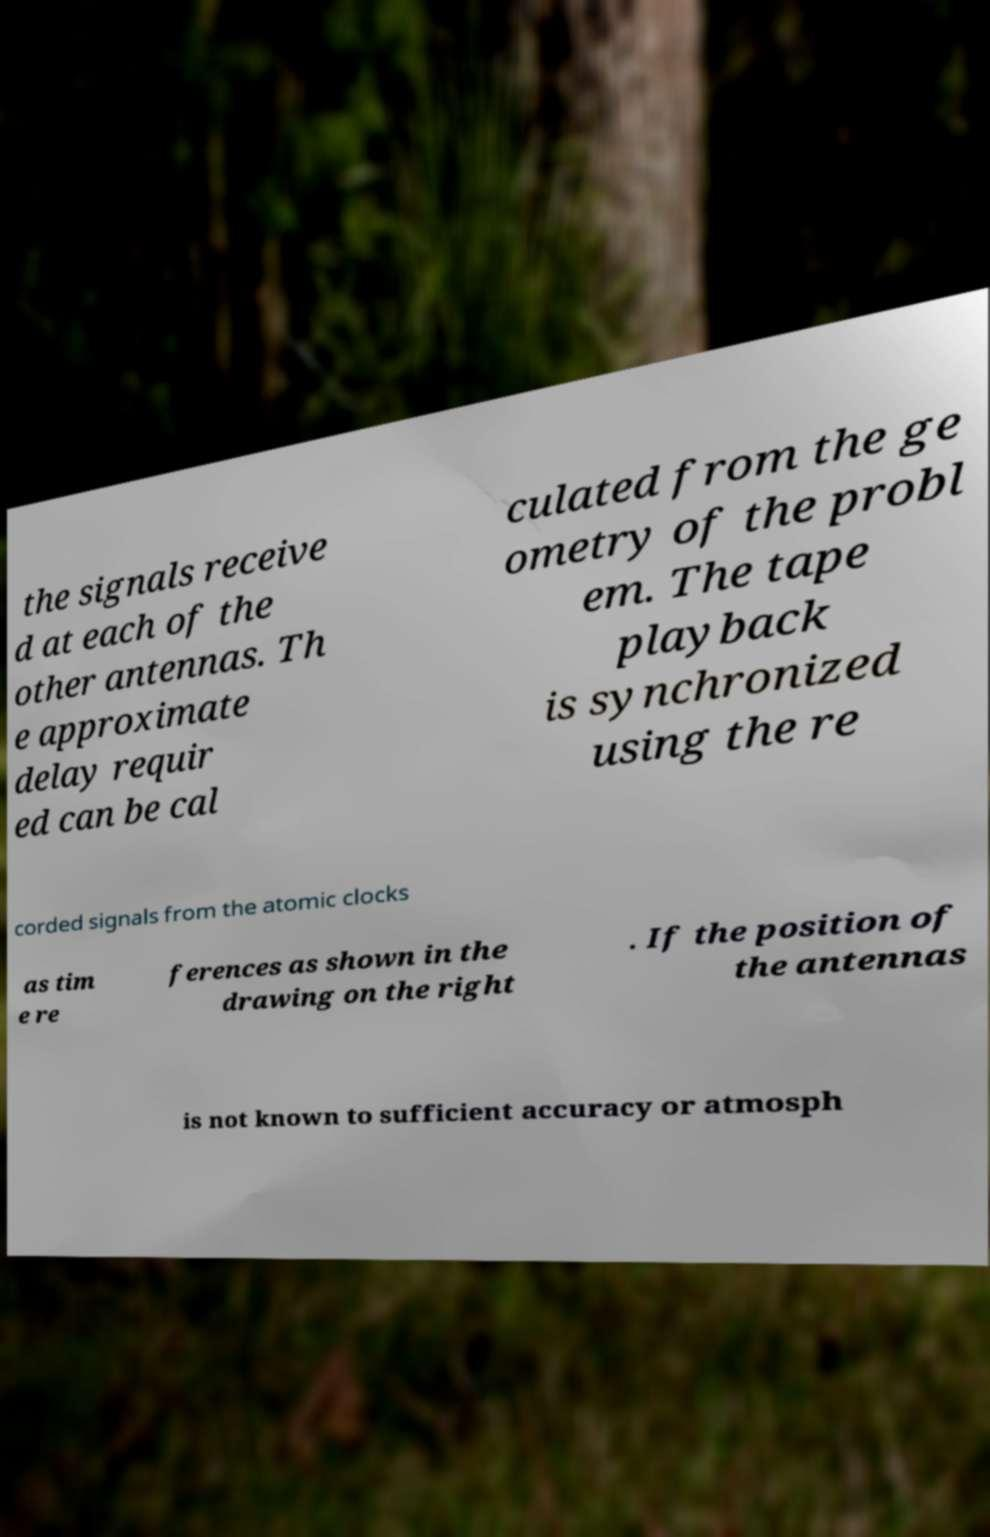Please identify and transcribe the text found in this image. the signals receive d at each of the other antennas. Th e approximate delay requir ed can be cal culated from the ge ometry of the probl em. The tape playback is synchronized using the re corded signals from the atomic clocks as tim e re ferences as shown in the drawing on the right . If the position of the antennas is not known to sufficient accuracy or atmosph 